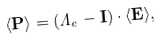<formula> <loc_0><loc_0><loc_500><loc_500>\langle \mathbf P \rangle = ( \Lambda _ { e } - \mathbf I ) \cdot \langle \mathbf E \rangle ,</formula> 